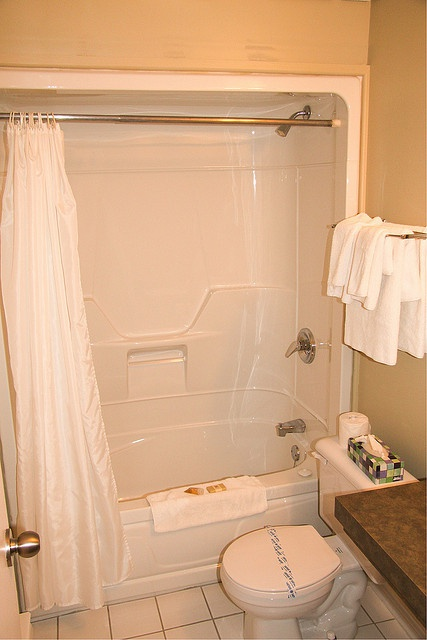Describe the objects in this image and their specific colors. I can see a toilet in tan and gray tones in this image. 